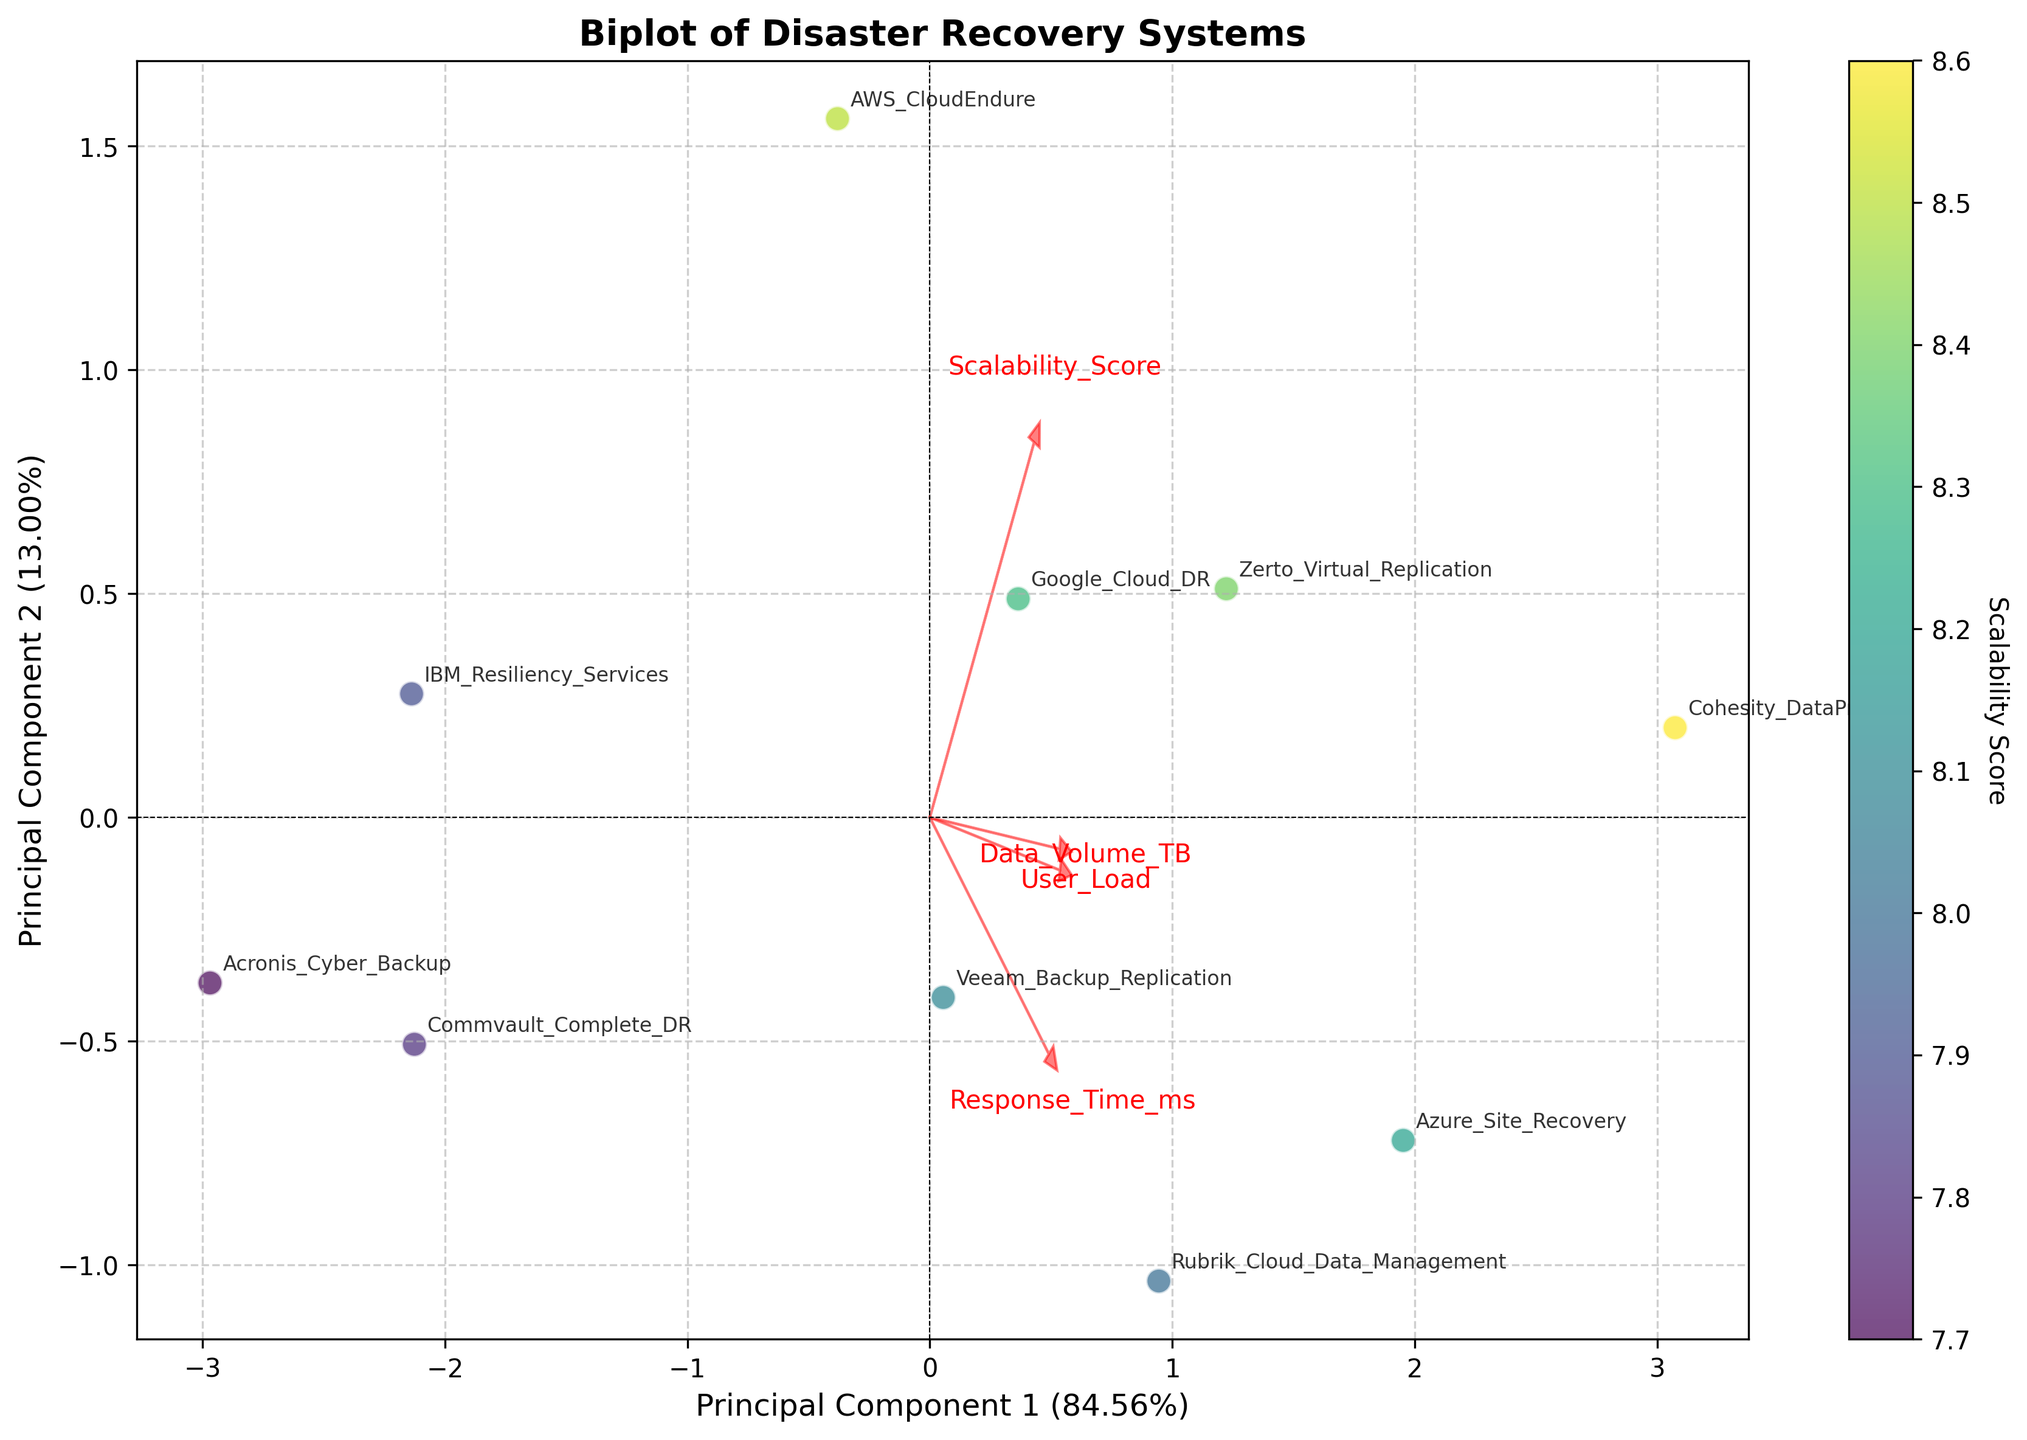What's the title of the plot? The title is written at the top of the plot. In this case, it is "Biplot of Disaster Recovery Systems".
Answer: Biplot of Disaster Recovery Systems How many data points are plotted in the figure? There are 10 disaster recovery systems mentioned in the data, and each of these systems corresponds to a data point on the plot.
Answer: 10 Which system has the highest scalability score? Each system's scalability score is color-coded on the plot. The system associated with the darkest color on the viridis color map will have the highest score. By checking the color bar, Cohesity_DataProtect appears to have the highest scalability score.
Answer: Cohesity_DataProtect What percentage of the total variance do the first two principal components explain together? The percentages of the variance explained by Principal Component 1 and Principal Component 2 are mentioned on the axes. Adding these values together will give the total variance explained by the two principal components. From the figure, PC1 explains 58.49% and PC2 explains 26.49%. The total is 58.49% + 26.49%.
Answer: 84.98% Which feature has the largest vector in the biplot? The length of the arrows representing the feature vectors shows their magnitude. The feature with the arrow extending the furthest from the origin has the largest vector. By inspecting the plot, 'User_Load' has the largest vector.
Answer: User_Load What is the general direction of the 'Scalability_Score' feature vector, and what does it imply? By looking at the arrow representing 'Scalability_Score', we note its direction. It points towards the lower right quadrant. This implies that systems with higher values in Principal Component 1 and moderate in Principal Component 2 tend to have better scalability scores.
Answer: Lower right What systems are closest to each other in terms of PCA components? By observing the distances between the points on the biplot, the systems Google_Cloud_DR, Zerto_Virtual_Replication, and Veeam_Backup_Replication appear to be closest to each other, indicating they have similar PCA components.
Answer: Google_Cloud_DR, Zerto_Virtual_Replication, Veeam_Backup_Replication Which two features are most correlated based on the biplot vectors? The biplot vectors that are closest to each other in direction indicate the most correlated features. The vectors for 'User_Load' and 'Data_Volume_TB' are fairly close to each other, suggesting a high correlation.
Answer: User_Load and Data_Volume_TB Which feature has the least influence on Principal Component 2? The influence of a feature on Principal Component 2 can be inferred by the length of the arrow in the y-direction. The feature with the shortest vertical length has the least influence. By looking at the plot, 'Response_Time_ms' seems to have the least vertical component.
Answer: Response_Time_ms In what general area of the plot are systems with high response times situated? Systems with higher response times will likely be positioned in a region indicated by the direction of the 'Response_Time_ms' vector. On the biplot, these points are situated in the lower left region.
Answer: Lower left 